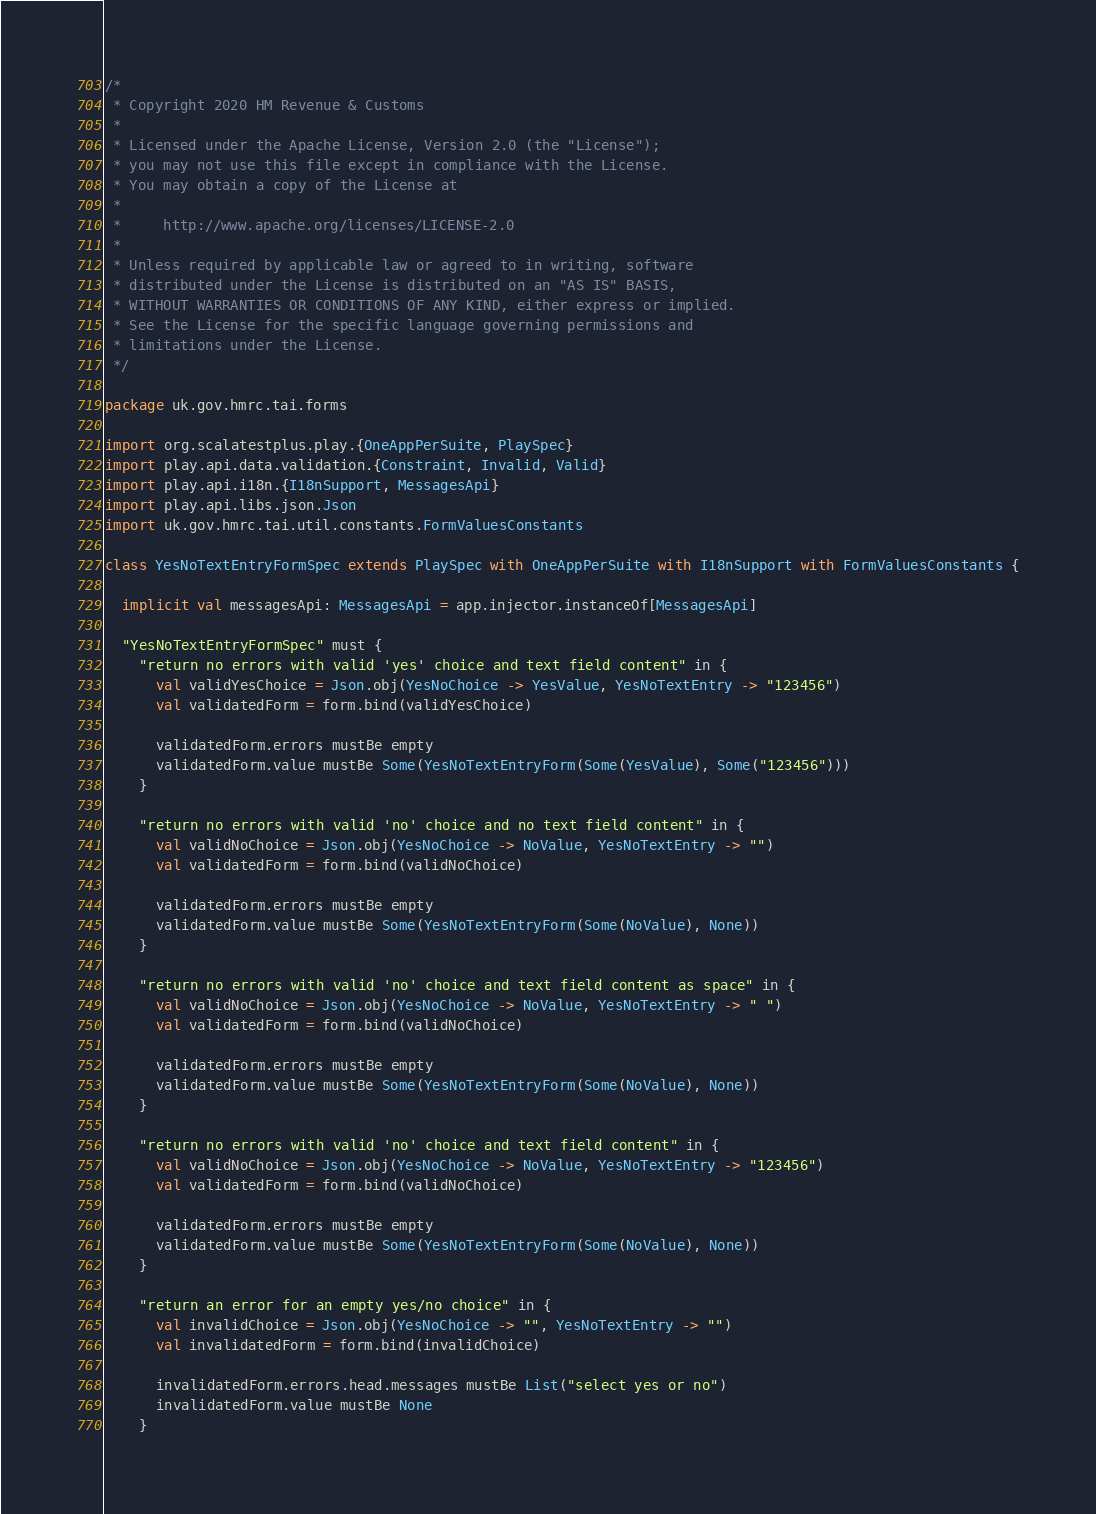<code> <loc_0><loc_0><loc_500><loc_500><_Scala_>/*
 * Copyright 2020 HM Revenue & Customs
 *
 * Licensed under the Apache License, Version 2.0 (the "License");
 * you may not use this file except in compliance with the License.
 * You may obtain a copy of the License at
 *
 *     http://www.apache.org/licenses/LICENSE-2.0
 *
 * Unless required by applicable law or agreed to in writing, software
 * distributed under the License is distributed on an "AS IS" BASIS,
 * WITHOUT WARRANTIES OR CONDITIONS OF ANY KIND, either express or implied.
 * See the License for the specific language governing permissions and
 * limitations under the License.
 */

package uk.gov.hmrc.tai.forms

import org.scalatestplus.play.{OneAppPerSuite, PlaySpec}
import play.api.data.validation.{Constraint, Invalid, Valid}
import play.api.i18n.{I18nSupport, MessagesApi}
import play.api.libs.json.Json
import uk.gov.hmrc.tai.util.constants.FormValuesConstants

class YesNoTextEntryFormSpec extends PlaySpec with OneAppPerSuite with I18nSupport with FormValuesConstants {

  implicit val messagesApi: MessagesApi = app.injector.instanceOf[MessagesApi]

  "YesNoTextEntryFormSpec" must {
    "return no errors with valid 'yes' choice and text field content" in {
      val validYesChoice = Json.obj(YesNoChoice -> YesValue, YesNoTextEntry -> "123456")
      val validatedForm = form.bind(validYesChoice)

      validatedForm.errors mustBe empty
      validatedForm.value mustBe Some(YesNoTextEntryForm(Some(YesValue), Some("123456")))
    }

    "return no errors with valid 'no' choice and no text field content" in {
      val validNoChoice = Json.obj(YesNoChoice -> NoValue, YesNoTextEntry -> "")
      val validatedForm = form.bind(validNoChoice)

      validatedForm.errors mustBe empty
      validatedForm.value mustBe Some(YesNoTextEntryForm(Some(NoValue), None))
    }

    "return no errors with valid 'no' choice and text field content as space" in {
      val validNoChoice = Json.obj(YesNoChoice -> NoValue, YesNoTextEntry -> " ")
      val validatedForm = form.bind(validNoChoice)

      validatedForm.errors mustBe empty
      validatedForm.value mustBe Some(YesNoTextEntryForm(Some(NoValue), None))
    }

    "return no errors with valid 'no' choice and text field content" in {
      val validNoChoice = Json.obj(YesNoChoice -> NoValue, YesNoTextEntry -> "123456")
      val validatedForm = form.bind(validNoChoice)

      validatedForm.errors mustBe empty
      validatedForm.value mustBe Some(YesNoTextEntryForm(Some(NoValue), None))
    }

    "return an error for an empty yes/no choice" in {
      val invalidChoice = Json.obj(YesNoChoice -> "", YesNoTextEntry -> "")
      val invalidatedForm = form.bind(invalidChoice)

      invalidatedForm.errors.head.messages mustBe List("select yes or no")
      invalidatedForm.value mustBe None
    }
</code> 